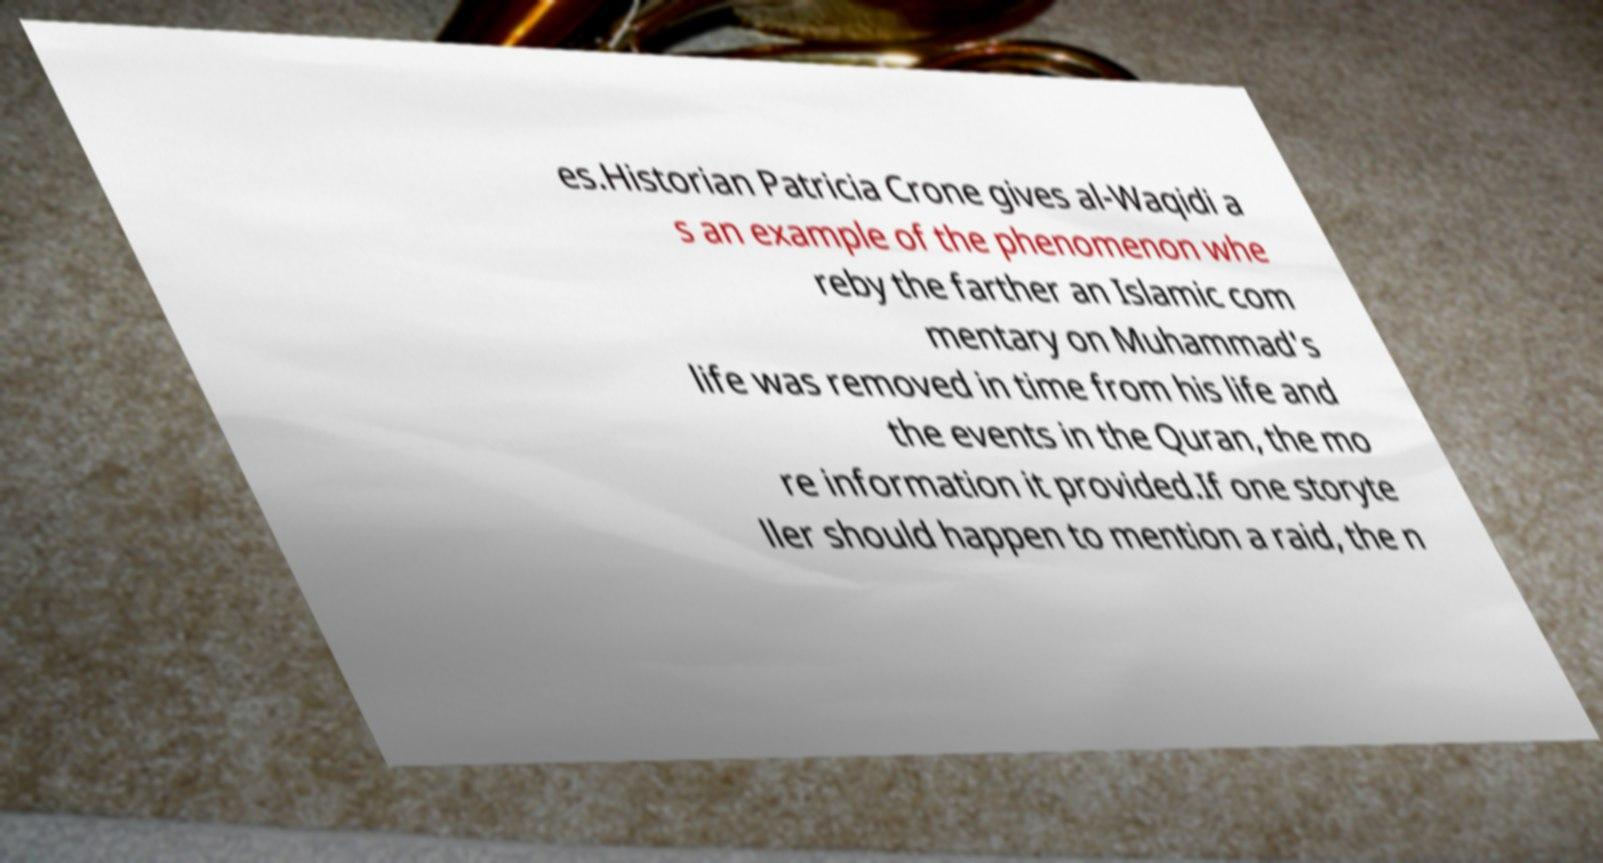There's text embedded in this image that I need extracted. Can you transcribe it verbatim? es.Historian Patricia Crone gives al-Waqidi a s an example of the phenomenon whe reby the farther an Islamic com mentary on Muhammad's life was removed in time from his life and the events in the Quran, the mo re information it provided.If one storyte ller should happen to mention a raid, the n 